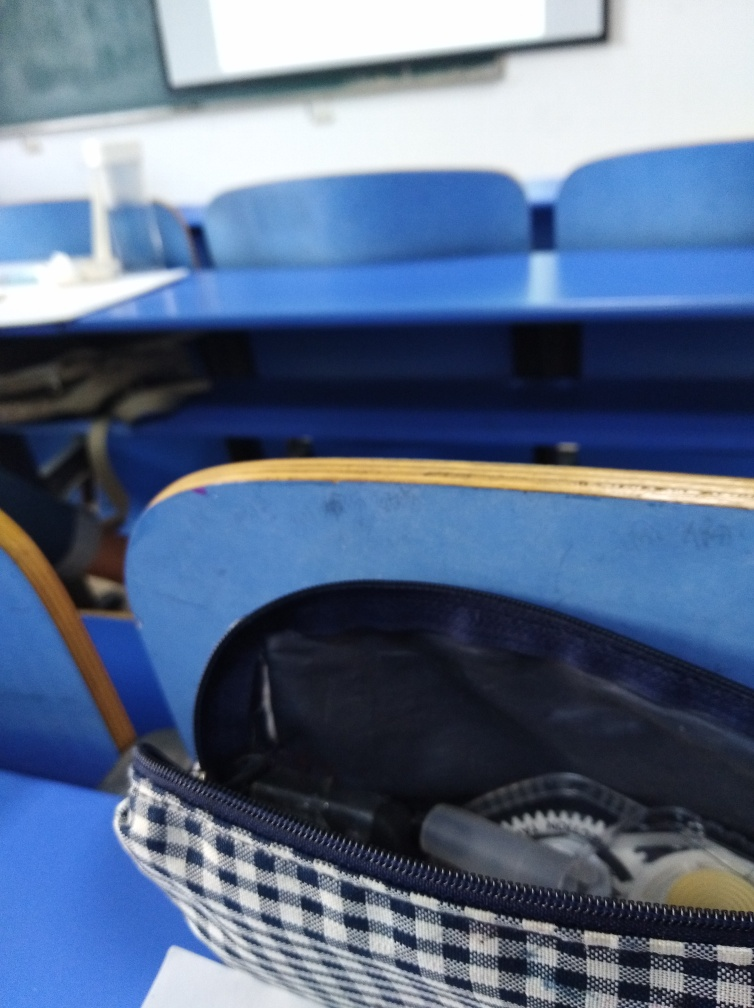What kind of environment is shown in this image? The image depicts an educational setting, likely a classroom, with individual desks and a whiteboard visible in the distance. The blue chairs and the arrangement suggest a formal learning environment. 